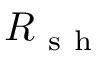Convert formula to latex. <formula><loc_0><loc_0><loc_500><loc_500>R _ { s h }</formula> 